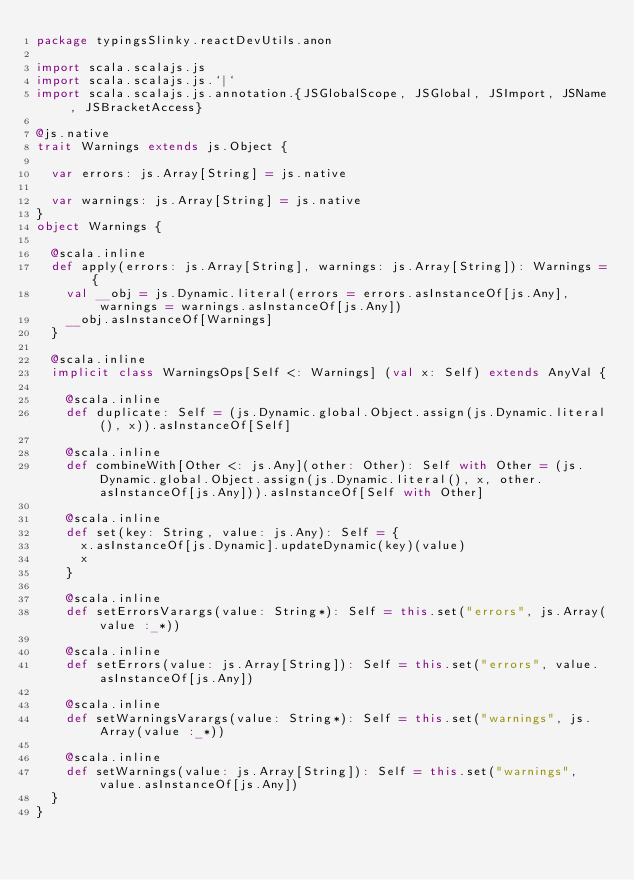<code> <loc_0><loc_0><loc_500><loc_500><_Scala_>package typingsSlinky.reactDevUtils.anon

import scala.scalajs.js
import scala.scalajs.js.`|`
import scala.scalajs.js.annotation.{JSGlobalScope, JSGlobal, JSImport, JSName, JSBracketAccess}

@js.native
trait Warnings extends js.Object {
  
  var errors: js.Array[String] = js.native
  
  var warnings: js.Array[String] = js.native
}
object Warnings {
  
  @scala.inline
  def apply(errors: js.Array[String], warnings: js.Array[String]): Warnings = {
    val __obj = js.Dynamic.literal(errors = errors.asInstanceOf[js.Any], warnings = warnings.asInstanceOf[js.Any])
    __obj.asInstanceOf[Warnings]
  }
  
  @scala.inline
  implicit class WarningsOps[Self <: Warnings] (val x: Self) extends AnyVal {
    
    @scala.inline
    def duplicate: Self = (js.Dynamic.global.Object.assign(js.Dynamic.literal(), x)).asInstanceOf[Self]
    
    @scala.inline
    def combineWith[Other <: js.Any](other: Other): Self with Other = (js.Dynamic.global.Object.assign(js.Dynamic.literal(), x, other.asInstanceOf[js.Any])).asInstanceOf[Self with Other]
    
    @scala.inline
    def set(key: String, value: js.Any): Self = {
      x.asInstanceOf[js.Dynamic].updateDynamic(key)(value)
      x
    }
    
    @scala.inline
    def setErrorsVarargs(value: String*): Self = this.set("errors", js.Array(value :_*))
    
    @scala.inline
    def setErrors(value: js.Array[String]): Self = this.set("errors", value.asInstanceOf[js.Any])
    
    @scala.inline
    def setWarningsVarargs(value: String*): Self = this.set("warnings", js.Array(value :_*))
    
    @scala.inline
    def setWarnings(value: js.Array[String]): Self = this.set("warnings", value.asInstanceOf[js.Any])
  }
}
</code> 